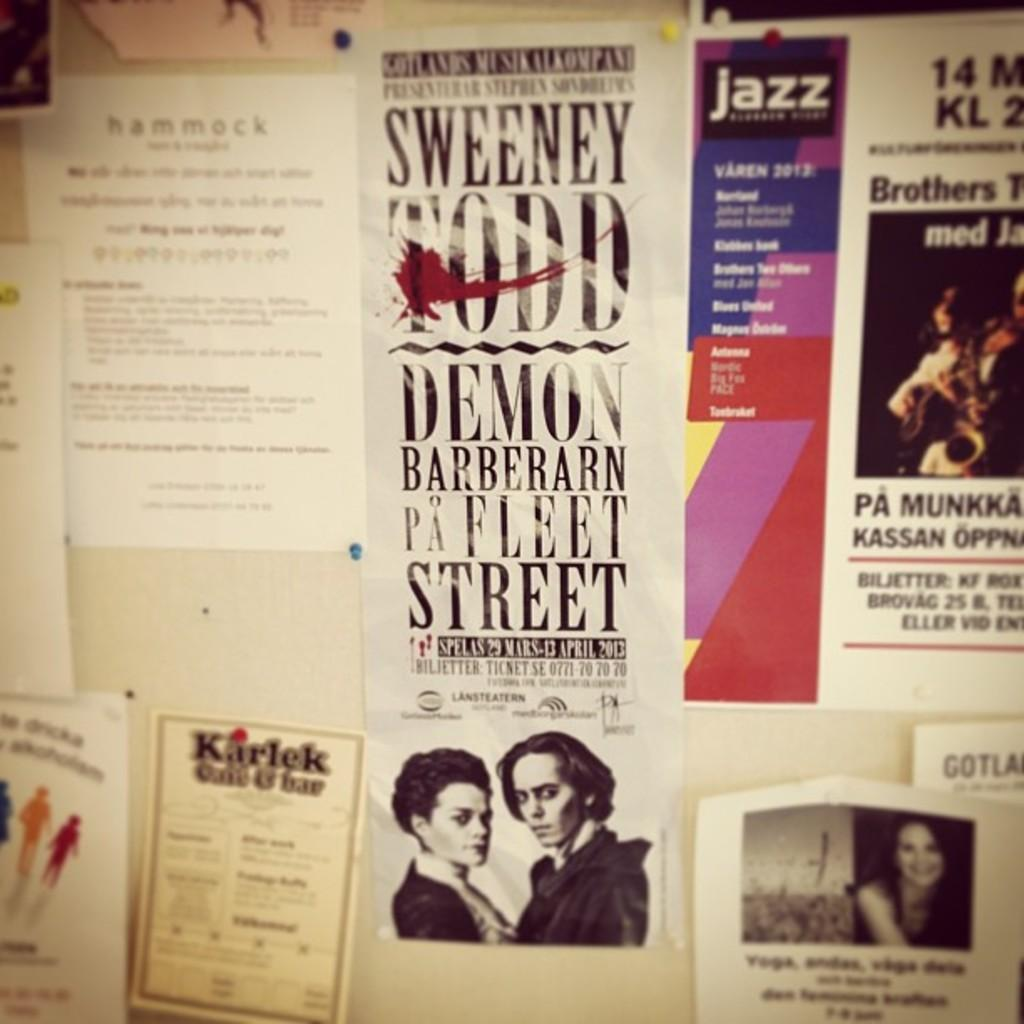<image>
Provide a brief description of the given image. Poster on the wall saying "Sweetney Todd" with a picture of a couple under. 